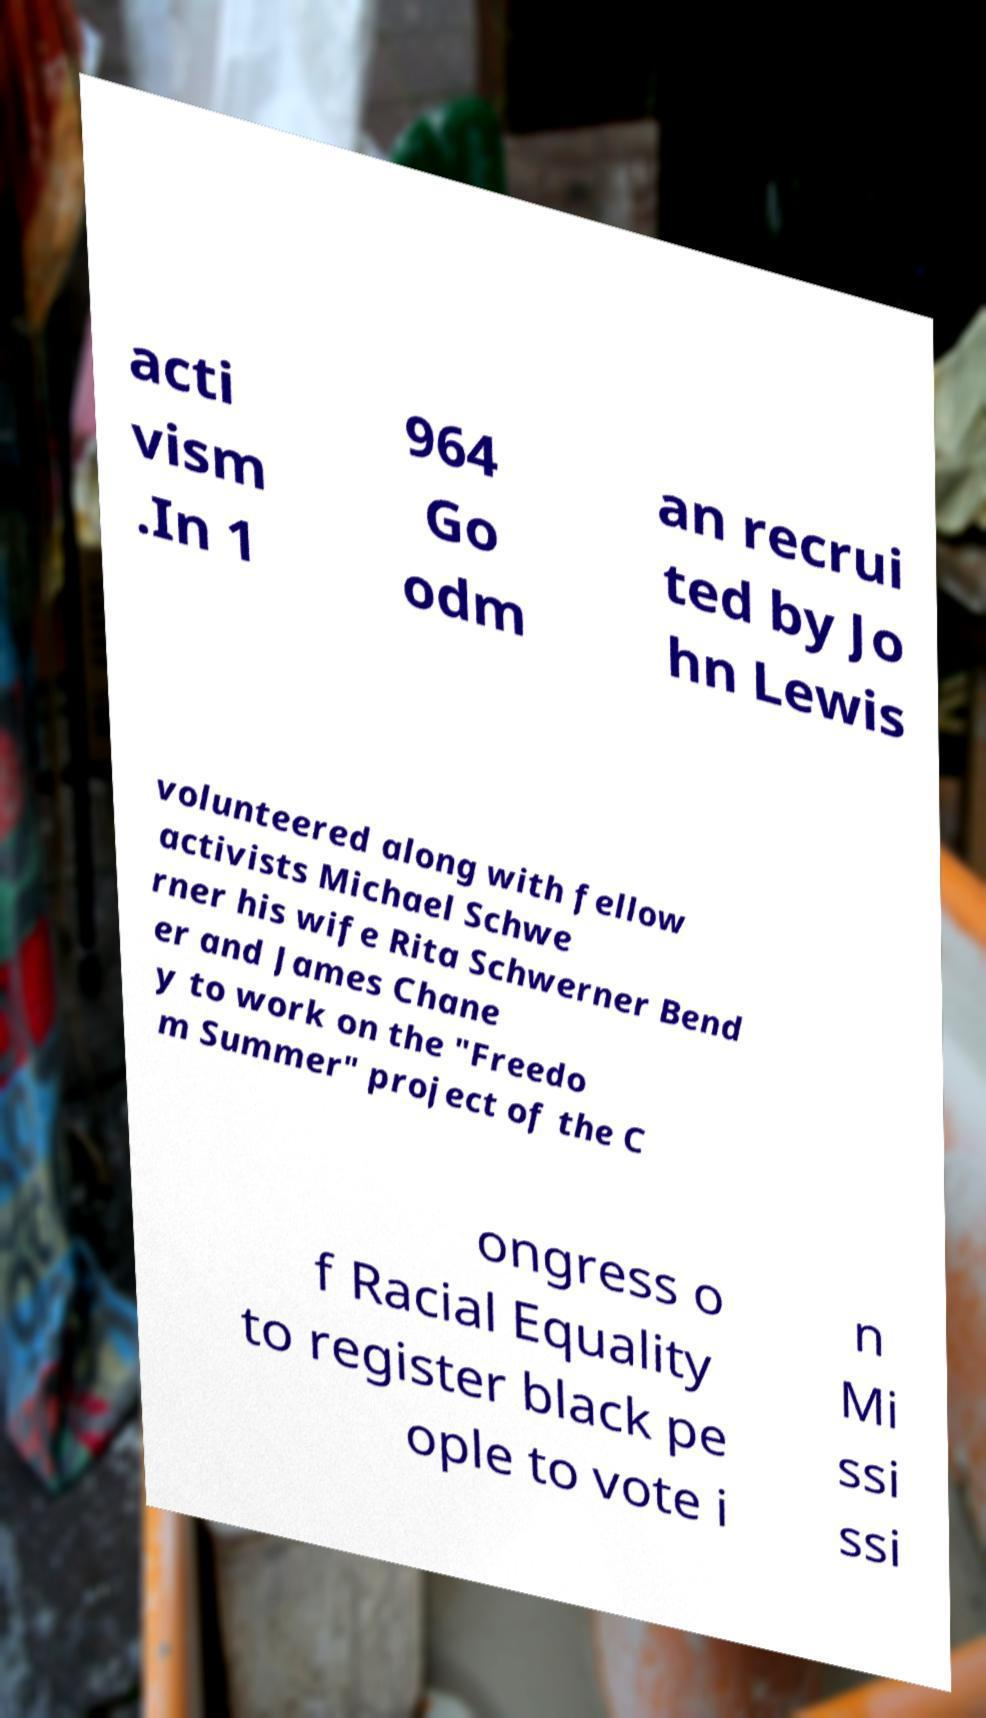Could you assist in decoding the text presented in this image and type it out clearly? acti vism .In 1 964 Go odm an recrui ted by Jo hn Lewis volunteered along with fellow activists Michael Schwe rner his wife Rita Schwerner Bend er and James Chane y to work on the "Freedo m Summer" project of the C ongress o f Racial Equality to register black pe ople to vote i n Mi ssi ssi 